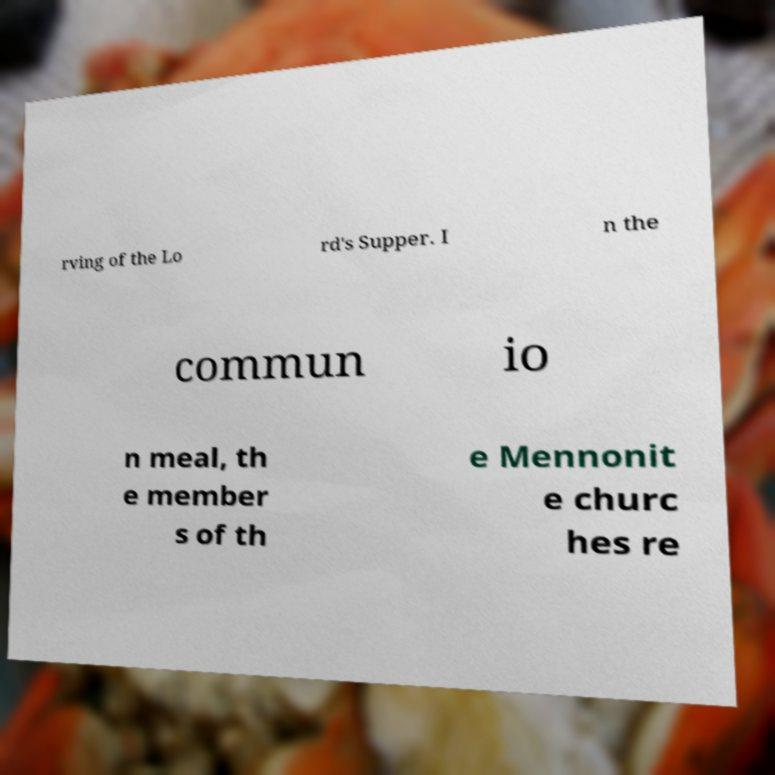For documentation purposes, I need the text within this image transcribed. Could you provide that? rving of the Lo rd's Supper. I n the commun io n meal, th e member s of th e Mennonit e churc hes re 